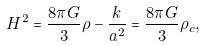<formula> <loc_0><loc_0><loc_500><loc_500>H ^ { 2 } = \frac { 8 \pi G } { 3 } \rho - \frac { k } { a ^ { 2 } } = \frac { 8 \pi G } { 3 } \rho _ { c } ,</formula> 